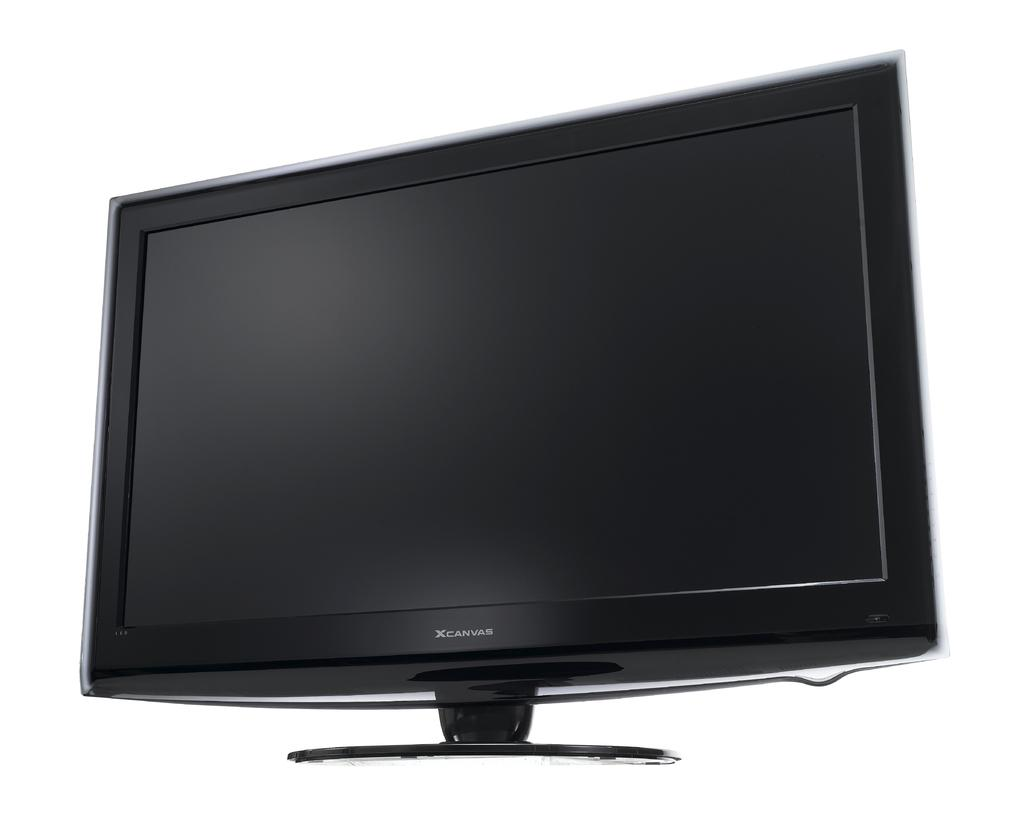<image>
Render a clear and concise summary of the photo. an Xcanvas computer monitor turned off. 